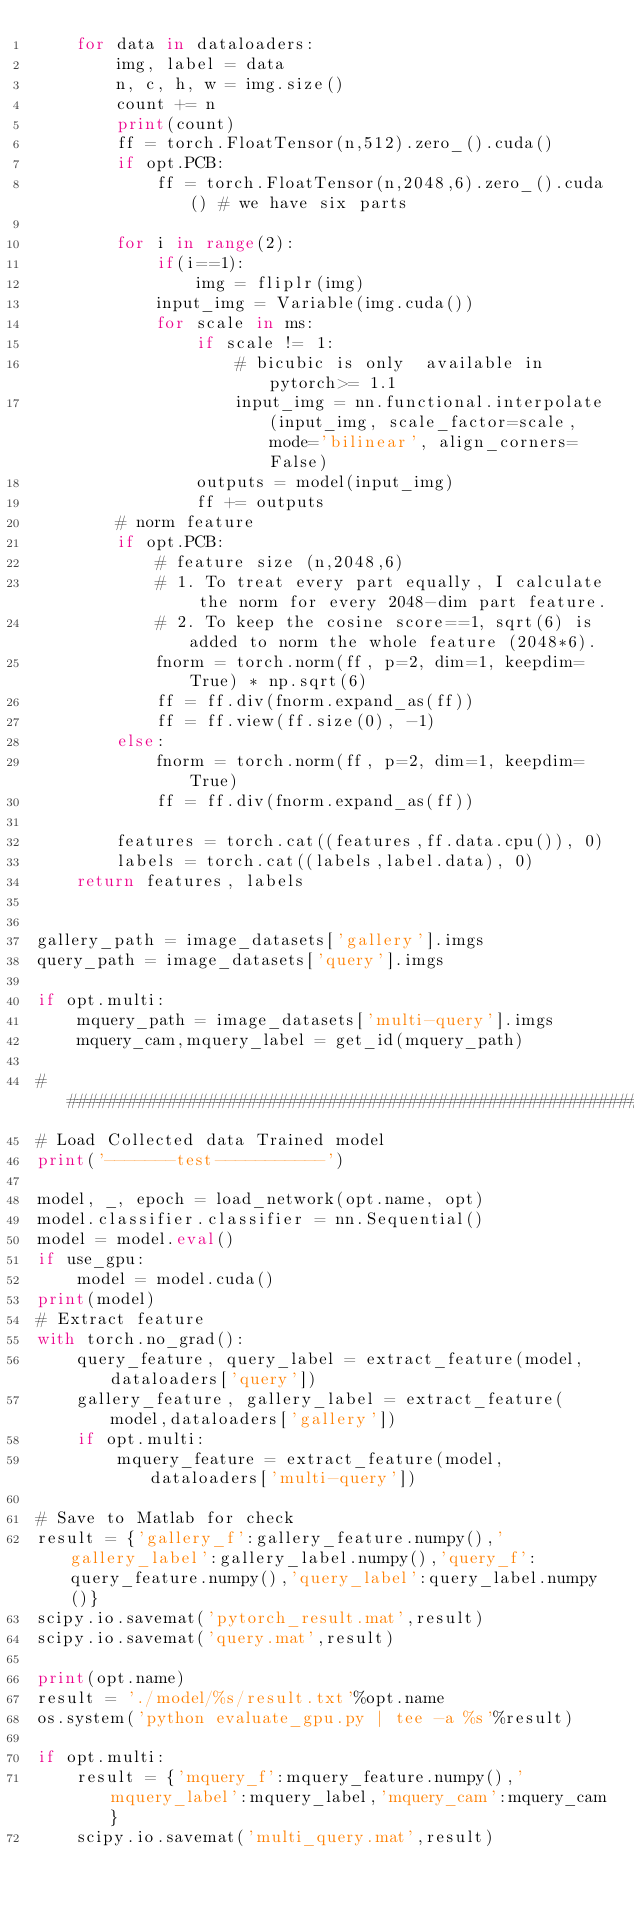Convert code to text. <code><loc_0><loc_0><loc_500><loc_500><_Python_>    for data in dataloaders:
        img, label = data
        n, c, h, w = img.size()
        count += n
        print(count)
        ff = torch.FloatTensor(n,512).zero_().cuda()
        if opt.PCB:
            ff = torch.FloatTensor(n,2048,6).zero_().cuda() # we have six parts

        for i in range(2):
            if(i==1):
                img = fliplr(img)
            input_img = Variable(img.cuda())
            for scale in ms:
                if scale != 1:
                    # bicubic is only  available in pytorch>= 1.1
                    input_img = nn.functional.interpolate(input_img, scale_factor=scale, mode='bilinear', align_corners=False)
                outputs = model(input_img) 
                ff += outputs
        # norm feature
        if opt.PCB:
            # feature size (n,2048,6)
            # 1. To treat every part equally, I calculate the norm for every 2048-dim part feature.
            # 2. To keep the cosine score==1, sqrt(6) is added to norm the whole feature (2048*6).
            fnorm = torch.norm(ff, p=2, dim=1, keepdim=True) * np.sqrt(6) 
            ff = ff.div(fnorm.expand_as(ff))
            ff = ff.view(ff.size(0), -1)
        else:
            fnorm = torch.norm(ff, p=2, dim=1, keepdim=True)
            ff = ff.div(fnorm.expand_as(ff))

        features = torch.cat((features,ff.data.cpu()), 0)
        labels = torch.cat((labels,label.data), 0)
    return features, labels


gallery_path = image_datasets['gallery'].imgs
query_path = image_datasets['query'].imgs

if opt.multi:
    mquery_path = image_datasets['multi-query'].imgs
    mquery_cam,mquery_label = get_id(mquery_path)

######################################################################
# Load Collected data Trained model
print('-------test-----------')

model, _, epoch = load_network(opt.name, opt)
model.classifier.classifier = nn.Sequential()
model = model.eval()
if use_gpu:
    model = model.cuda()
print(model)
# Extract feature
with torch.no_grad():
    query_feature, query_label = extract_feature(model,dataloaders['query'])
    gallery_feature, gallery_label = extract_feature(model,dataloaders['gallery'])
    if opt.multi:
        mquery_feature = extract_feature(model,dataloaders['multi-query'])
    
# Save to Matlab for check
result = {'gallery_f':gallery_feature.numpy(),'gallery_label':gallery_label.numpy(),'query_f':query_feature.numpy(),'query_label':query_label.numpy()}
scipy.io.savemat('pytorch_result.mat',result)
scipy.io.savemat('query.mat',result)

print(opt.name)
result = './model/%s/result.txt'%opt.name
os.system('python evaluate_gpu.py | tee -a %s'%result)

if opt.multi:
    result = {'mquery_f':mquery_feature.numpy(),'mquery_label':mquery_label,'mquery_cam':mquery_cam}
    scipy.io.savemat('multi_query.mat',result)
</code> 